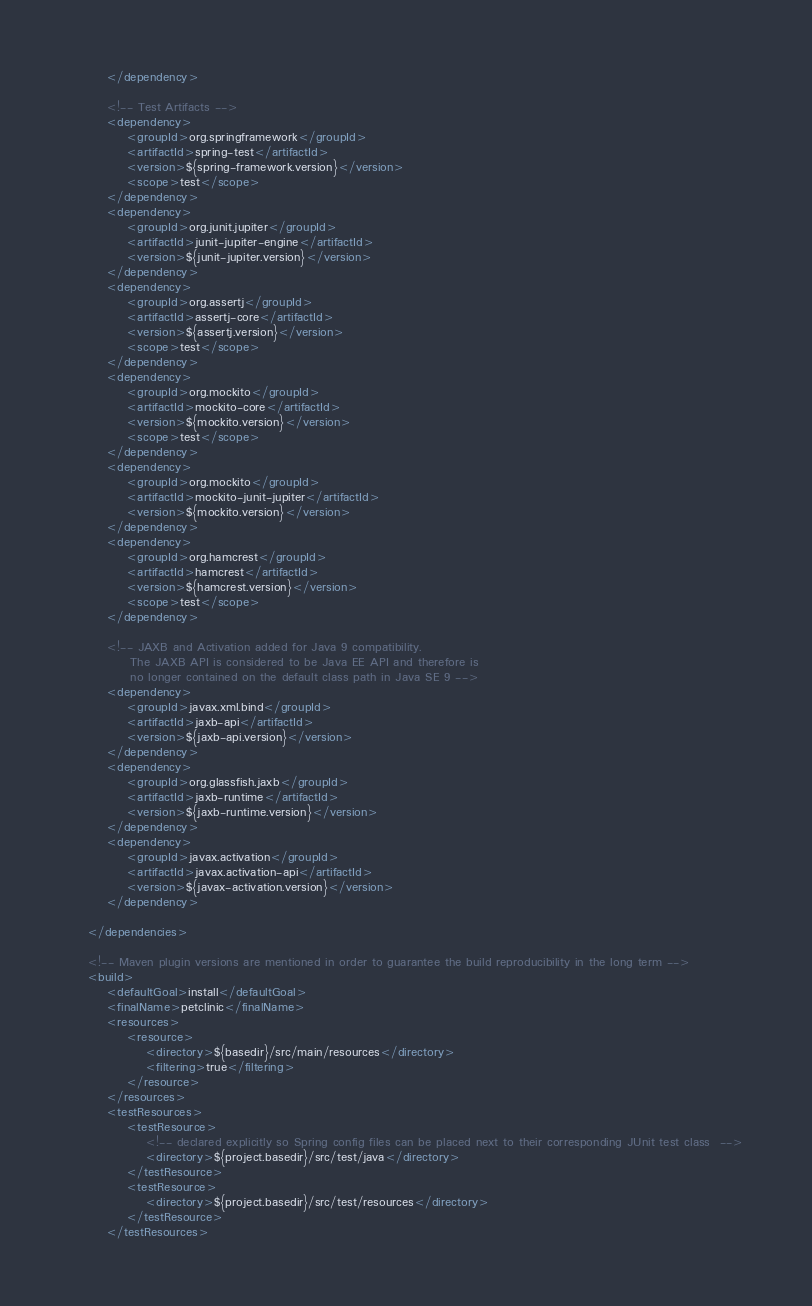<code> <loc_0><loc_0><loc_500><loc_500><_XML_>        </dependency>

        <!-- Test Artifacts -->
        <dependency>
            <groupId>org.springframework</groupId>
            <artifactId>spring-test</artifactId>
            <version>${spring-framework.version}</version>
            <scope>test</scope>
        </dependency>
        <dependency>
            <groupId>org.junit.jupiter</groupId>
            <artifactId>junit-jupiter-engine</artifactId>
            <version>${junit-jupiter.version}</version>
        </dependency>
        <dependency>
            <groupId>org.assertj</groupId>
            <artifactId>assertj-core</artifactId>
            <version>${assertj.version}</version>
            <scope>test</scope>
        </dependency>
        <dependency>
            <groupId>org.mockito</groupId>
            <artifactId>mockito-core</artifactId>
            <version>${mockito.version}</version>
            <scope>test</scope>
        </dependency>
        <dependency>
            <groupId>org.mockito</groupId>
            <artifactId>mockito-junit-jupiter</artifactId>
            <version>${mockito.version}</version>
        </dependency>
        <dependency>
            <groupId>org.hamcrest</groupId>
            <artifactId>hamcrest</artifactId>
            <version>${hamcrest.version}</version>
            <scope>test</scope>
        </dependency>

        <!-- JAXB and Activation added for Java 9 compatibility.
             The JAXB API is considered to be Java EE API and therefore is
             no longer contained on the default class path in Java SE 9 -->
        <dependency>
            <groupId>javax.xml.bind</groupId>
            <artifactId>jaxb-api</artifactId>
            <version>${jaxb-api.version}</version>
        </dependency>
        <dependency>
            <groupId>org.glassfish.jaxb</groupId>
            <artifactId>jaxb-runtime</artifactId>
            <version>${jaxb-runtime.version}</version>
        </dependency>
        <dependency>
            <groupId>javax.activation</groupId>
            <artifactId>javax.activation-api</artifactId>
            <version>${javax-activation.version}</version>
        </dependency>

    </dependencies>

    <!-- Maven plugin versions are mentioned in order to guarantee the build reproducibility in the long term -->
    <build>
        <defaultGoal>install</defaultGoal>
        <finalName>petclinic</finalName>
        <resources>
            <resource>
                <directory>${basedir}/src/main/resources</directory>
                <filtering>true</filtering>
            </resource>
        </resources>
        <testResources>
            <testResource>
                <!-- declared explicitly so Spring config files can be placed next to their corresponding JUnit test class  -->
                <directory>${project.basedir}/src/test/java</directory>
            </testResource>
            <testResource>
                <directory>${project.basedir}/src/test/resources</directory>
            </testResource>
        </testResources></code> 